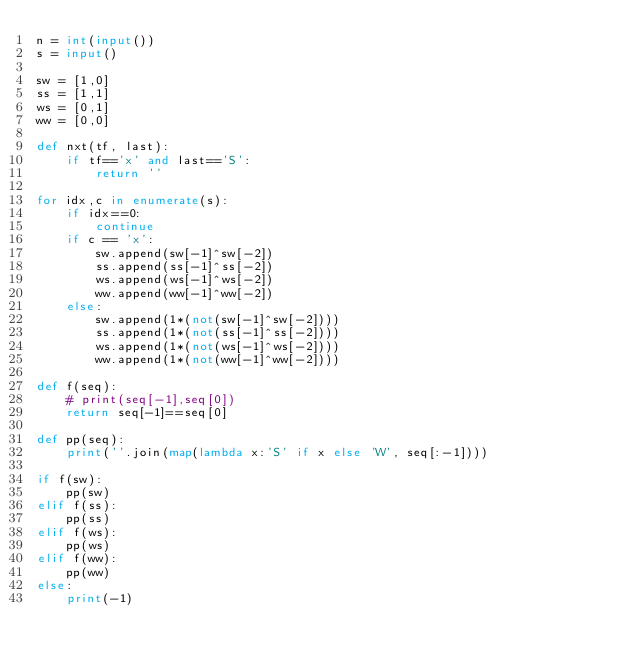Convert code to text. <code><loc_0><loc_0><loc_500><loc_500><_Python_>n = int(input())
s = input()

sw = [1,0]
ss = [1,1]
ws = [0,1]
ww = [0,0]

def nxt(tf, last):
    if tf=='x' and last=='S':
        return ''

for idx,c in enumerate(s):
    if idx==0:
        continue
    if c == 'x':
        sw.append(sw[-1]^sw[-2])
        ss.append(ss[-1]^ss[-2])
        ws.append(ws[-1]^ws[-2])
        ww.append(ww[-1]^ww[-2])
    else:
        sw.append(1*(not(sw[-1]^sw[-2])))
        ss.append(1*(not(ss[-1]^ss[-2])))
        ws.append(1*(not(ws[-1]^ws[-2])))
        ww.append(1*(not(ww[-1]^ww[-2])))

def f(seq):
    # print(seq[-1],seq[0])
    return seq[-1]==seq[0]

def pp(seq):
    print(''.join(map(lambda x:'S' if x else 'W', seq[:-1])))

if f(sw):
    pp(sw)
elif f(ss):
    pp(ss)
elif f(ws):
    pp(ws)
elif f(ww):
    pp(ww)
else:
    print(-1)
</code> 